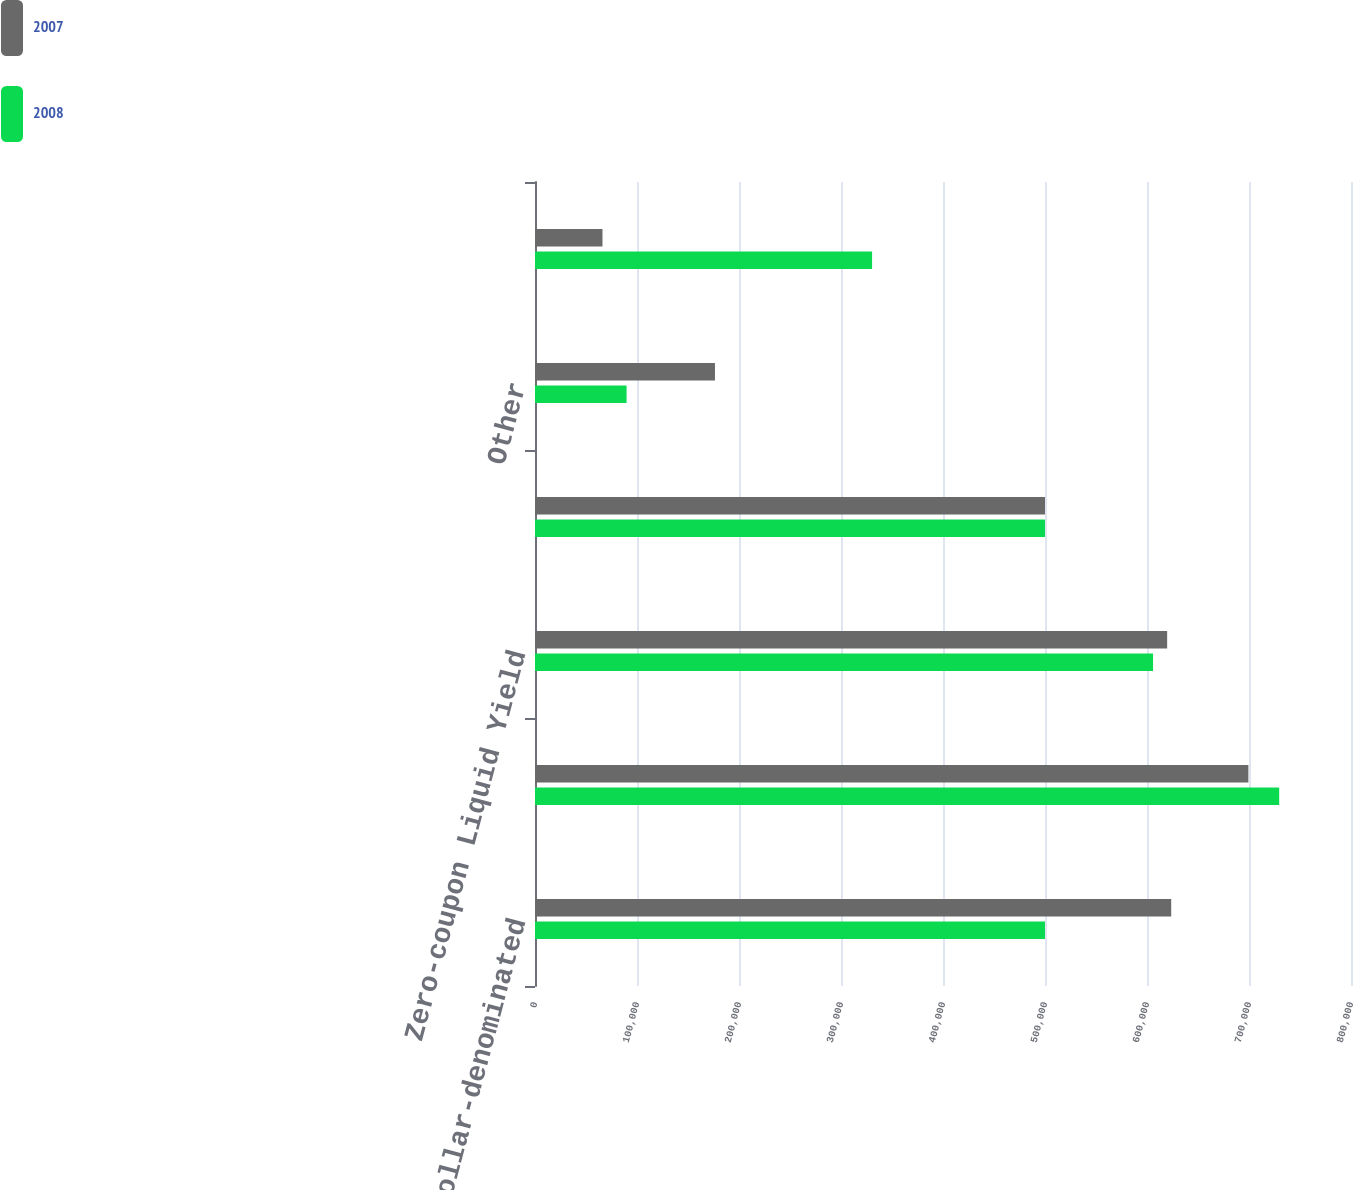Convert chart. <chart><loc_0><loc_0><loc_500><loc_500><stacked_bar_chart><ecel><fcel>US dollar-denominated<fcel>45 guaranteed Eurobond Notes<fcel>Zero-coupon Liquid Yield<fcel>5625 Senior Notes due 2018<fcel>Other<fcel>Less - currently payable<nl><fcel>2007<fcel>623728<fcel>699400<fcel>619757<fcel>500000<fcel>176444<fcel>66159<nl><fcel>2008<fcel>500000<fcel>729600<fcel>605938<fcel>500000<fcel>89780<fcel>330480<nl></chart> 